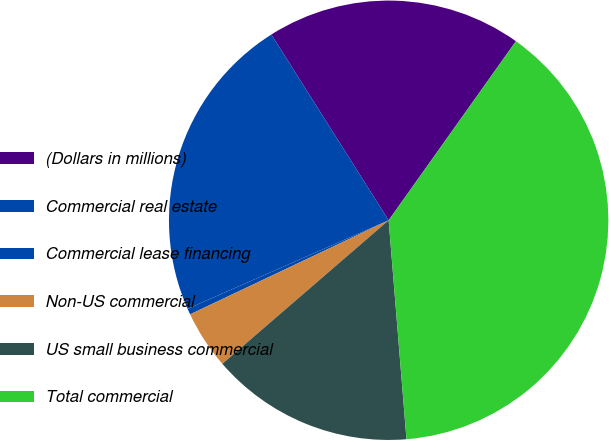Convert chart to OTSL. <chart><loc_0><loc_0><loc_500><loc_500><pie_chart><fcel>(Dollars in millions)<fcel>Commercial real estate<fcel>Commercial lease financing<fcel>Non-US commercial<fcel>US small business commercial<fcel>Total commercial<nl><fcel>18.8%<fcel>22.64%<fcel>0.44%<fcel>4.29%<fcel>14.96%<fcel>38.87%<nl></chart> 